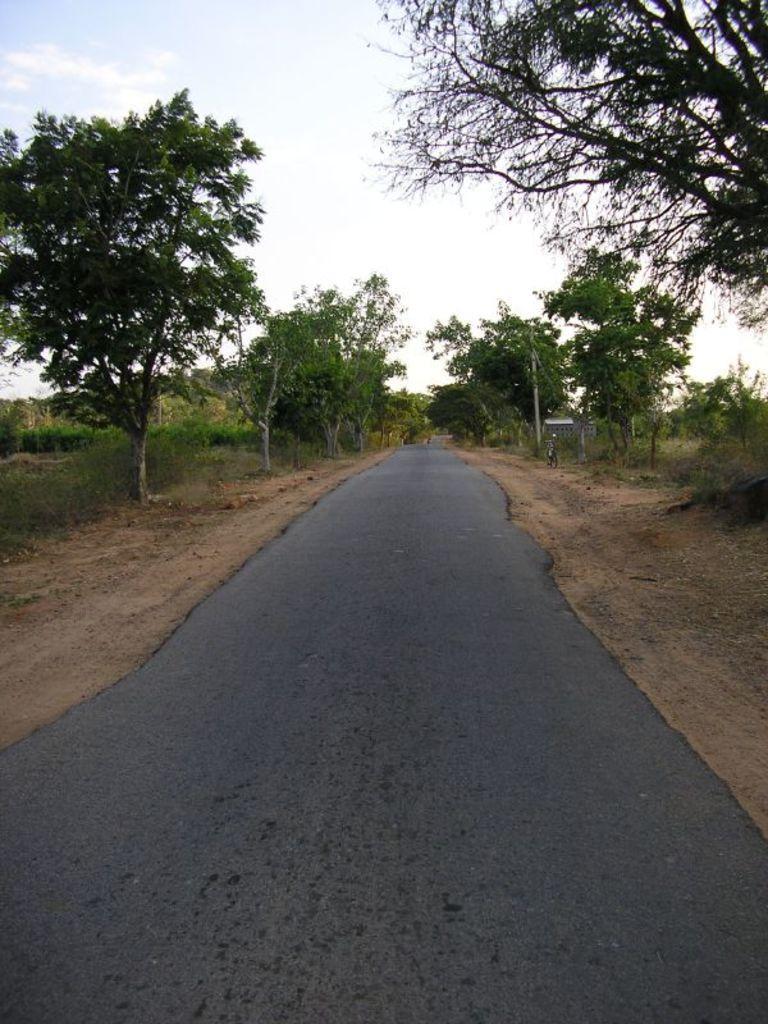Could you give a brief overview of what you see in this image? In the center of the image, we can see road and in the background, there are trees and we can see a pole and bicycle. At the top, there is sky. 